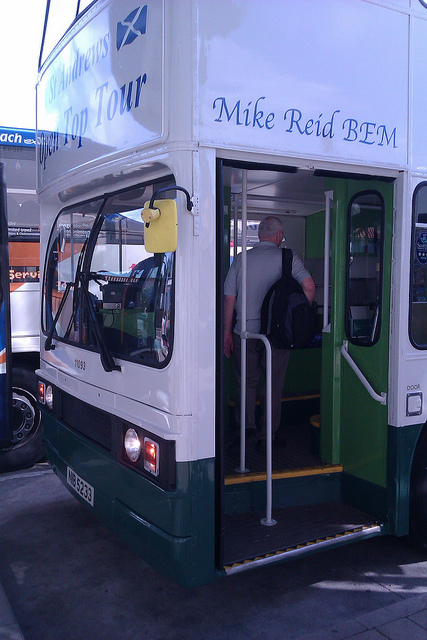<image>What country is this? I am not sure which country this is. It could be Scotland, England, New Zealand or Sweden. What country is this? It is not clear what country is shown in the image. It can be either Scotland, England, New Zealand, Sweden, or Europe. 